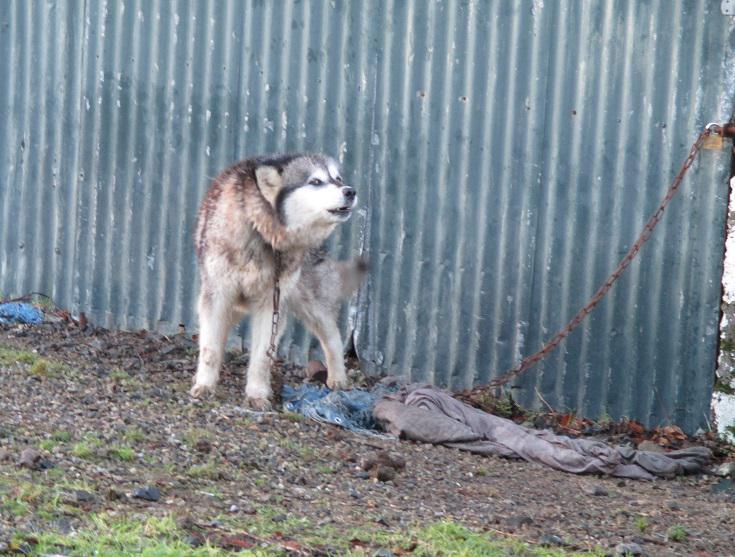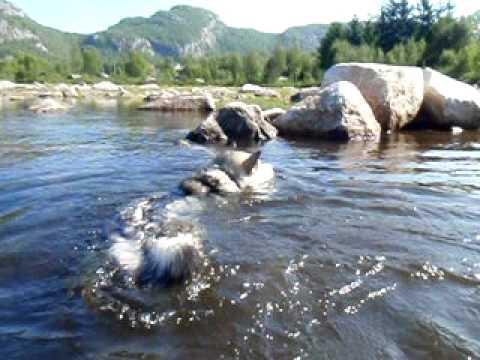The first image is the image on the left, the second image is the image on the right. Considering the images on both sides, is "All of the dogs are in the water." valid? Answer yes or no. No. The first image is the image on the left, the second image is the image on the right. Given the left and right images, does the statement "Each image shows a dog in the water, with one of the dog's pictured facing directly forward and wearing a red collar." hold true? Answer yes or no. No. 